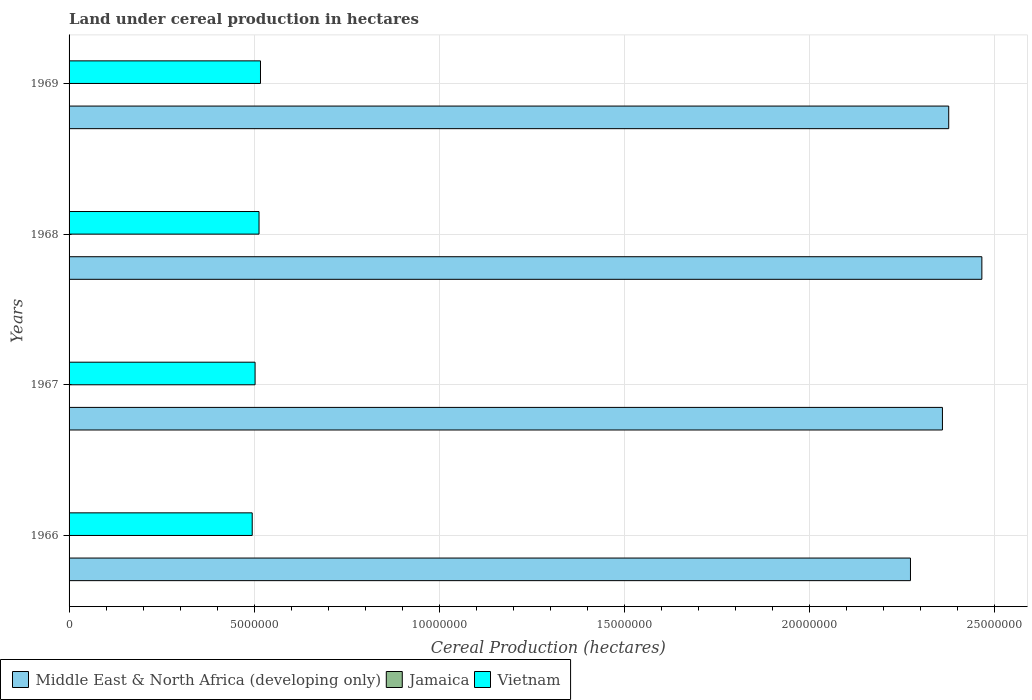How many different coloured bars are there?
Make the answer very short. 3. How many groups of bars are there?
Offer a terse response. 4. Are the number of bars on each tick of the Y-axis equal?
Provide a short and direct response. Yes. How many bars are there on the 4th tick from the bottom?
Keep it short and to the point. 3. What is the label of the 3rd group of bars from the top?
Your answer should be very brief. 1967. In how many cases, is the number of bars for a given year not equal to the number of legend labels?
Keep it short and to the point. 0. What is the land under cereal production in Jamaica in 1968?
Make the answer very short. 3980. Across all years, what is the maximum land under cereal production in Middle East & North Africa (developing only)?
Provide a succinct answer. 2.47e+07. Across all years, what is the minimum land under cereal production in Jamaica?
Ensure brevity in your answer.  3590. In which year was the land under cereal production in Jamaica maximum?
Your response must be concise. 1966. In which year was the land under cereal production in Jamaica minimum?
Make the answer very short. 1967. What is the total land under cereal production in Middle East & North Africa (developing only) in the graph?
Ensure brevity in your answer.  9.48e+07. What is the difference between the land under cereal production in Vietnam in 1967 and that in 1968?
Ensure brevity in your answer.  -1.07e+05. What is the difference between the land under cereal production in Vietnam in 1967 and the land under cereal production in Jamaica in 1968?
Give a very brief answer. 5.02e+06. What is the average land under cereal production in Jamaica per year?
Offer a terse response. 4316.25. In the year 1969, what is the difference between the land under cereal production in Middle East & North Africa (developing only) and land under cereal production in Vietnam?
Your response must be concise. 1.86e+07. What is the ratio of the land under cereal production in Middle East & North Africa (developing only) in 1966 to that in 1968?
Provide a short and direct response. 0.92. Is the difference between the land under cereal production in Middle East & North Africa (developing only) in 1967 and 1968 greater than the difference between the land under cereal production in Vietnam in 1967 and 1968?
Provide a short and direct response. No. What is the difference between the highest and the second highest land under cereal production in Vietnam?
Ensure brevity in your answer.  3.92e+04. What is the difference between the highest and the lowest land under cereal production in Vietnam?
Provide a succinct answer. 2.23e+05. In how many years, is the land under cereal production in Middle East & North Africa (developing only) greater than the average land under cereal production in Middle East & North Africa (developing only) taken over all years?
Your answer should be very brief. 2. What does the 2nd bar from the top in 1966 represents?
Give a very brief answer. Jamaica. What does the 2nd bar from the bottom in 1968 represents?
Ensure brevity in your answer.  Jamaica. Are all the bars in the graph horizontal?
Offer a very short reply. Yes. How many years are there in the graph?
Offer a very short reply. 4. What is the difference between two consecutive major ticks on the X-axis?
Provide a short and direct response. 5.00e+06. Does the graph contain any zero values?
Provide a succinct answer. No. Does the graph contain grids?
Your response must be concise. Yes. How are the legend labels stacked?
Provide a short and direct response. Horizontal. What is the title of the graph?
Offer a terse response. Land under cereal production in hectares. Does "Virgin Islands" appear as one of the legend labels in the graph?
Your response must be concise. No. What is the label or title of the X-axis?
Offer a very short reply. Cereal Production (hectares). What is the label or title of the Y-axis?
Make the answer very short. Years. What is the Cereal Production (hectares) in Middle East & North Africa (developing only) in 1966?
Ensure brevity in your answer.  2.27e+07. What is the Cereal Production (hectares) of Jamaica in 1966?
Your answer should be very brief. 5985. What is the Cereal Production (hectares) of Vietnam in 1966?
Your answer should be compact. 4.95e+06. What is the Cereal Production (hectares) in Middle East & North Africa (developing only) in 1967?
Keep it short and to the point. 2.36e+07. What is the Cereal Production (hectares) of Jamaica in 1967?
Keep it short and to the point. 3590. What is the Cereal Production (hectares) in Vietnam in 1967?
Give a very brief answer. 5.03e+06. What is the Cereal Production (hectares) in Middle East & North Africa (developing only) in 1968?
Provide a succinct answer. 2.47e+07. What is the Cereal Production (hectares) of Jamaica in 1968?
Your answer should be compact. 3980. What is the Cereal Production (hectares) in Vietnam in 1968?
Your answer should be very brief. 5.13e+06. What is the Cereal Production (hectares) of Middle East & North Africa (developing only) in 1969?
Ensure brevity in your answer.  2.38e+07. What is the Cereal Production (hectares) of Jamaica in 1969?
Provide a succinct answer. 3710. What is the Cereal Production (hectares) in Vietnam in 1969?
Offer a terse response. 5.17e+06. Across all years, what is the maximum Cereal Production (hectares) in Middle East & North Africa (developing only)?
Your answer should be very brief. 2.47e+07. Across all years, what is the maximum Cereal Production (hectares) in Jamaica?
Make the answer very short. 5985. Across all years, what is the maximum Cereal Production (hectares) of Vietnam?
Give a very brief answer. 5.17e+06. Across all years, what is the minimum Cereal Production (hectares) of Middle East & North Africa (developing only)?
Give a very brief answer. 2.27e+07. Across all years, what is the minimum Cereal Production (hectares) of Jamaica?
Your answer should be very brief. 3590. Across all years, what is the minimum Cereal Production (hectares) of Vietnam?
Provide a short and direct response. 4.95e+06. What is the total Cereal Production (hectares) in Middle East & North Africa (developing only) in the graph?
Your answer should be compact. 9.48e+07. What is the total Cereal Production (hectares) in Jamaica in the graph?
Give a very brief answer. 1.73e+04. What is the total Cereal Production (hectares) in Vietnam in the graph?
Your answer should be very brief. 2.03e+07. What is the difference between the Cereal Production (hectares) of Middle East & North Africa (developing only) in 1966 and that in 1967?
Offer a terse response. -8.64e+05. What is the difference between the Cereal Production (hectares) of Jamaica in 1966 and that in 1967?
Keep it short and to the point. 2395. What is the difference between the Cereal Production (hectares) in Vietnam in 1966 and that in 1967?
Ensure brevity in your answer.  -7.70e+04. What is the difference between the Cereal Production (hectares) of Middle East & North Africa (developing only) in 1966 and that in 1968?
Ensure brevity in your answer.  -1.93e+06. What is the difference between the Cereal Production (hectares) in Jamaica in 1966 and that in 1968?
Give a very brief answer. 2005. What is the difference between the Cereal Production (hectares) in Vietnam in 1966 and that in 1968?
Make the answer very short. -1.84e+05. What is the difference between the Cereal Production (hectares) of Middle East & North Africa (developing only) in 1966 and that in 1969?
Your answer should be compact. -1.03e+06. What is the difference between the Cereal Production (hectares) in Jamaica in 1966 and that in 1969?
Make the answer very short. 2275. What is the difference between the Cereal Production (hectares) of Vietnam in 1966 and that in 1969?
Provide a short and direct response. -2.23e+05. What is the difference between the Cereal Production (hectares) of Middle East & North Africa (developing only) in 1967 and that in 1968?
Keep it short and to the point. -1.06e+06. What is the difference between the Cereal Production (hectares) in Jamaica in 1967 and that in 1968?
Offer a terse response. -390. What is the difference between the Cereal Production (hectares) of Vietnam in 1967 and that in 1968?
Provide a succinct answer. -1.07e+05. What is the difference between the Cereal Production (hectares) in Middle East & North Africa (developing only) in 1967 and that in 1969?
Provide a short and direct response. -1.70e+05. What is the difference between the Cereal Production (hectares) of Jamaica in 1967 and that in 1969?
Offer a very short reply. -120. What is the difference between the Cereal Production (hectares) in Vietnam in 1967 and that in 1969?
Make the answer very short. -1.46e+05. What is the difference between the Cereal Production (hectares) of Middle East & North Africa (developing only) in 1968 and that in 1969?
Your answer should be very brief. 8.95e+05. What is the difference between the Cereal Production (hectares) in Jamaica in 1968 and that in 1969?
Provide a succinct answer. 270. What is the difference between the Cereal Production (hectares) of Vietnam in 1968 and that in 1969?
Your answer should be very brief. -3.92e+04. What is the difference between the Cereal Production (hectares) of Middle East & North Africa (developing only) in 1966 and the Cereal Production (hectares) of Jamaica in 1967?
Your answer should be very brief. 2.27e+07. What is the difference between the Cereal Production (hectares) in Middle East & North Africa (developing only) in 1966 and the Cereal Production (hectares) in Vietnam in 1967?
Offer a terse response. 1.77e+07. What is the difference between the Cereal Production (hectares) in Jamaica in 1966 and the Cereal Production (hectares) in Vietnam in 1967?
Provide a short and direct response. -5.02e+06. What is the difference between the Cereal Production (hectares) of Middle East & North Africa (developing only) in 1966 and the Cereal Production (hectares) of Jamaica in 1968?
Your answer should be compact. 2.27e+07. What is the difference between the Cereal Production (hectares) of Middle East & North Africa (developing only) in 1966 and the Cereal Production (hectares) of Vietnam in 1968?
Give a very brief answer. 1.76e+07. What is the difference between the Cereal Production (hectares) in Jamaica in 1966 and the Cereal Production (hectares) in Vietnam in 1968?
Your answer should be very brief. -5.13e+06. What is the difference between the Cereal Production (hectares) of Middle East & North Africa (developing only) in 1966 and the Cereal Production (hectares) of Jamaica in 1969?
Your answer should be compact. 2.27e+07. What is the difference between the Cereal Production (hectares) in Middle East & North Africa (developing only) in 1966 and the Cereal Production (hectares) in Vietnam in 1969?
Provide a succinct answer. 1.76e+07. What is the difference between the Cereal Production (hectares) in Jamaica in 1966 and the Cereal Production (hectares) in Vietnam in 1969?
Provide a succinct answer. -5.17e+06. What is the difference between the Cereal Production (hectares) of Middle East & North Africa (developing only) in 1967 and the Cereal Production (hectares) of Jamaica in 1968?
Keep it short and to the point. 2.36e+07. What is the difference between the Cereal Production (hectares) in Middle East & North Africa (developing only) in 1967 and the Cereal Production (hectares) in Vietnam in 1968?
Offer a very short reply. 1.85e+07. What is the difference between the Cereal Production (hectares) of Jamaica in 1967 and the Cereal Production (hectares) of Vietnam in 1968?
Your answer should be very brief. -5.13e+06. What is the difference between the Cereal Production (hectares) in Middle East & North Africa (developing only) in 1967 and the Cereal Production (hectares) in Jamaica in 1969?
Your response must be concise. 2.36e+07. What is the difference between the Cereal Production (hectares) in Middle East & North Africa (developing only) in 1967 and the Cereal Production (hectares) in Vietnam in 1969?
Make the answer very short. 1.84e+07. What is the difference between the Cereal Production (hectares) in Jamaica in 1967 and the Cereal Production (hectares) in Vietnam in 1969?
Ensure brevity in your answer.  -5.17e+06. What is the difference between the Cereal Production (hectares) in Middle East & North Africa (developing only) in 1968 and the Cereal Production (hectares) in Jamaica in 1969?
Keep it short and to the point. 2.47e+07. What is the difference between the Cereal Production (hectares) in Middle East & North Africa (developing only) in 1968 and the Cereal Production (hectares) in Vietnam in 1969?
Offer a terse response. 1.95e+07. What is the difference between the Cereal Production (hectares) of Jamaica in 1968 and the Cereal Production (hectares) of Vietnam in 1969?
Provide a succinct answer. -5.17e+06. What is the average Cereal Production (hectares) of Middle East & North Africa (developing only) per year?
Provide a short and direct response. 2.37e+07. What is the average Cereal Production (hectares) of Jamaica per year?
Offer a very short reply. 4316.25. What is the average Cereal Production (hectares) of Vietnam per year?
Your answer should be compact. 5.07e+06. In the year 1966, what is the difference between the Cereal Production (hectares) of Middle East & North Africa (developing only) and Cereal Production (hectares) of Jamaica?
Make the answer very short. 2.27e+07. In the year 1966, what is the difference between the Cereal Production (hectares) in Middle East & North Africa (developing only) and Cereal Production (hectares) in Vietnam?
Give a very brief answer. 1.78e+07. In the year 1966, what is the difference between the Cereal Production (hectares) of Jamaica and Cereal Production (hectares) of Vietnam?
Give a very brief answer. -4.94e+06. In the year 1967, what is the difference between the Cereal Production (hectares) in Middle East & North Africa (developing only) and Cereal Production (hectares) in Jamaica?
Provide a succinct answer. 2.36e+07. In the year 1967, what is the difference between the Cereal Production (hectares) of Middle East & North Africa (developing only) and Cereal Production (hectares) of Vietnam?
Offer a very short reply. 1.86e+07. In the year 1967, what is the difference between the Cereal Production (hectares) of Jamaica and Cereal Production (hectares) of Vietnam?
Your answer should be compact. -5.02e+06. In the year 1968, what is the difference between the Cereal Production (hectares) in Middle East & North Africa (developing only) and Cereal Production (hectares) in Jamaica?
Offer a very short reply. 2.47e+07. In the year 1968, what is the difference between the Cereal Production (hectares) in Middle East & North Africa (developing only) and Cereal Production (hectares) in Vietnam?
Your response must be concise. 1.95e+07. In the year 1968, what is the difference between the Cereal Production (hectares) in Jamaica and Cereal Production (hectares) in Vietnam?
Provide a succinct answer. -5.13e+06. In the year 1969, what is the difference between the Cereal Production (hectares) in Middle East & North Africa (developing only) and Cereal Production (hectares) in Jamaica?
Give a very brief answer. 2.38e+07. In the year 1969, what is the difference between the Cereal Production (hectares) in Middle East & North Africa (developing only) and Cereal Production (hectares) in Vietnam?
Ensure brevity in your answer.  1.86e+07. In the year 1969, what is the difference between the Cereal Production (hectares) of Jamaica and Cereal Production (hectares) of Vietnam?
Provide a succinct answer. -5.17e+06. What is the ratio of the Cereal Production (hectares) of Middle East & North Africa (developing only) in 1966 to that in 1967?
Your answer should be very brief. 0.96. What is the ratio of the Cereal Production (hectares) in Jamaica in 1966 to that in 1967?
Give a very brief answer. 1.67. What is the ratio of the Cereal Production (hectares) of Vietnam in 1966 to that in 1967?
Give a very brief answer. 0.98. What is the ratio of the Cereal Production (hectares) of Middle East & North Africa (developing only) in 1966 to that in 1968?
Your response must be concise. 0.92. What is the ratio of the Cereal Production (hectares) of Jamaica in 1966 to that in 1968?
Keep it short and to the point. 1.5. What is the ratio of the Cereal Production (hectares) of Vietnam in 1966 to that in 1968?
Keep it short and to the point. 0.96. What is the ratio of the Cereal Production (hectares) of Middle East & North Africa (developing only) in 1966 to that in 1969?
Your answer should be compact. 0.96. What is the ratio of the Cereal Production (hectares) in Jamaica in 1966 to that in 1969?
Your response must be concise. 1.61. What is the ratio of the Cereal Production (hectares) of Vietnam in 1966 to that in 1969?
Your response must be concise. 0.96. What is the ratio of the Cereal Production (hectares) in Middle East & North Africa (developing only) in 1967 to that in 1968?
Make the answer very short. 0.96. What is the ratio of the Cereal Production (hectares) in Jamaica in 1967 to that in 1968?
Ensure brevity in your answer.  0.9. What is the ratio of the Cereal Production (hectares) in Vietnam in 1967 to that in 1968?
Your answer should be very brief. 0.98. What is the ratio of the Cereal Production (hectares) of Vietnam in 1967 to that in 1969?
Your answer should be compact. 0.97. What is the ratio of the Cereal Production (hectares) of Middle East & North Africa (developing only) in 1968 to that in 1969?
Offer a very short reply. 1.04. What is the ratio of the Cereal Production (hectares) of Jamaica in 1968 to that in 1969?
Ensure brevity in your answer.  1.07. What is the difference between the highest and the second highest Cereal Production (hectares) in Middle East & North Africa (developing only)?
Offer a very short reply. 8.95e+05. What is the difference between the highest and the second highest Cereal Production (hectares) in Jamaica?
Keep it short and to the point. 2005. What is the difference between the highest and the second highest Cereal Production (hectares) of Vietnam?
Your answer should be compact. 3.92e+04. What is the difference between the highest and the lowest Cereal Production (hectares) of Middle East & North Africa (developing only)?
Your answer should be compact. 1.93e+06. What is the difference between the highest and the lowest Cereal Production (hectares) of Jamaica?
Make the answer very short. 2395. What is the difference between the highest and the lowest Cereal Production (hectares) in Vietnam?
Ensure brevity in your answer.  2.23e+05. 